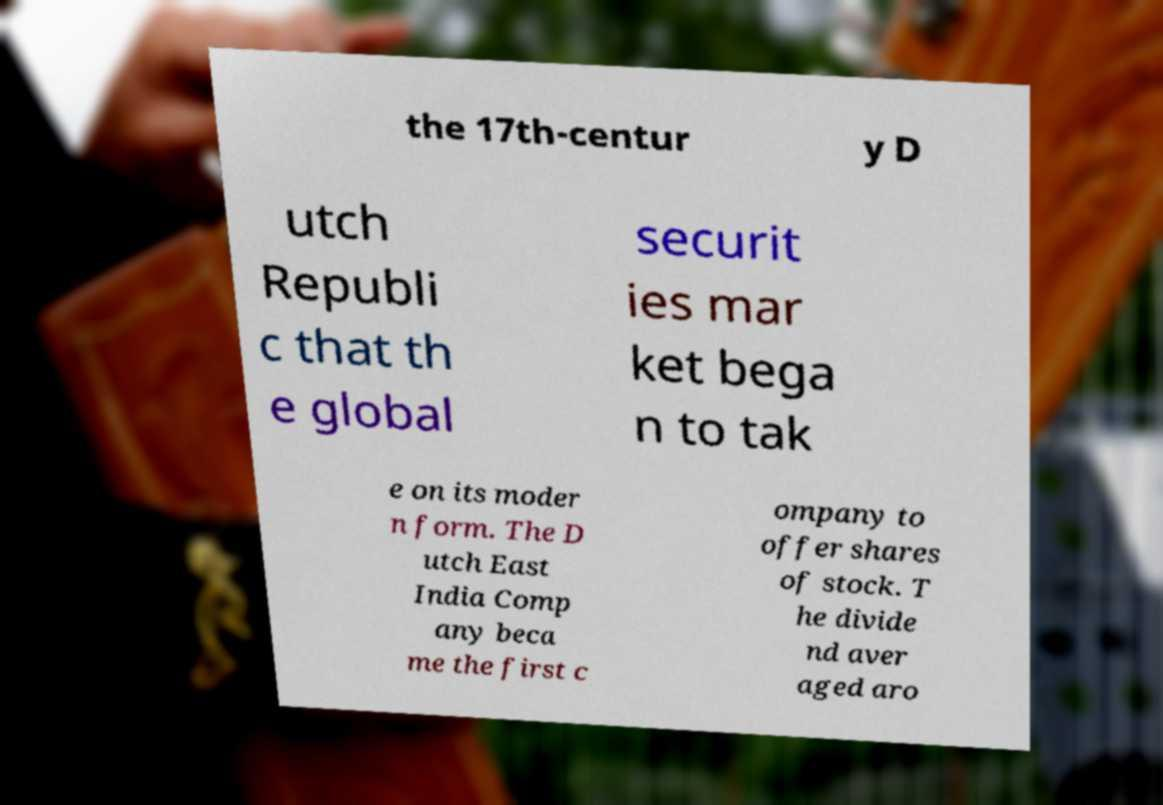Could you assist in decoding the text presented in this image and type it out clearly? the 17th-centur y D utch Republi c that th e global securit ies mar ket bega n to tak e on its moder n form. The D utch East India Comp any beca me the first c ompany to offer shares of stock. T he divide nd aver aged aro 